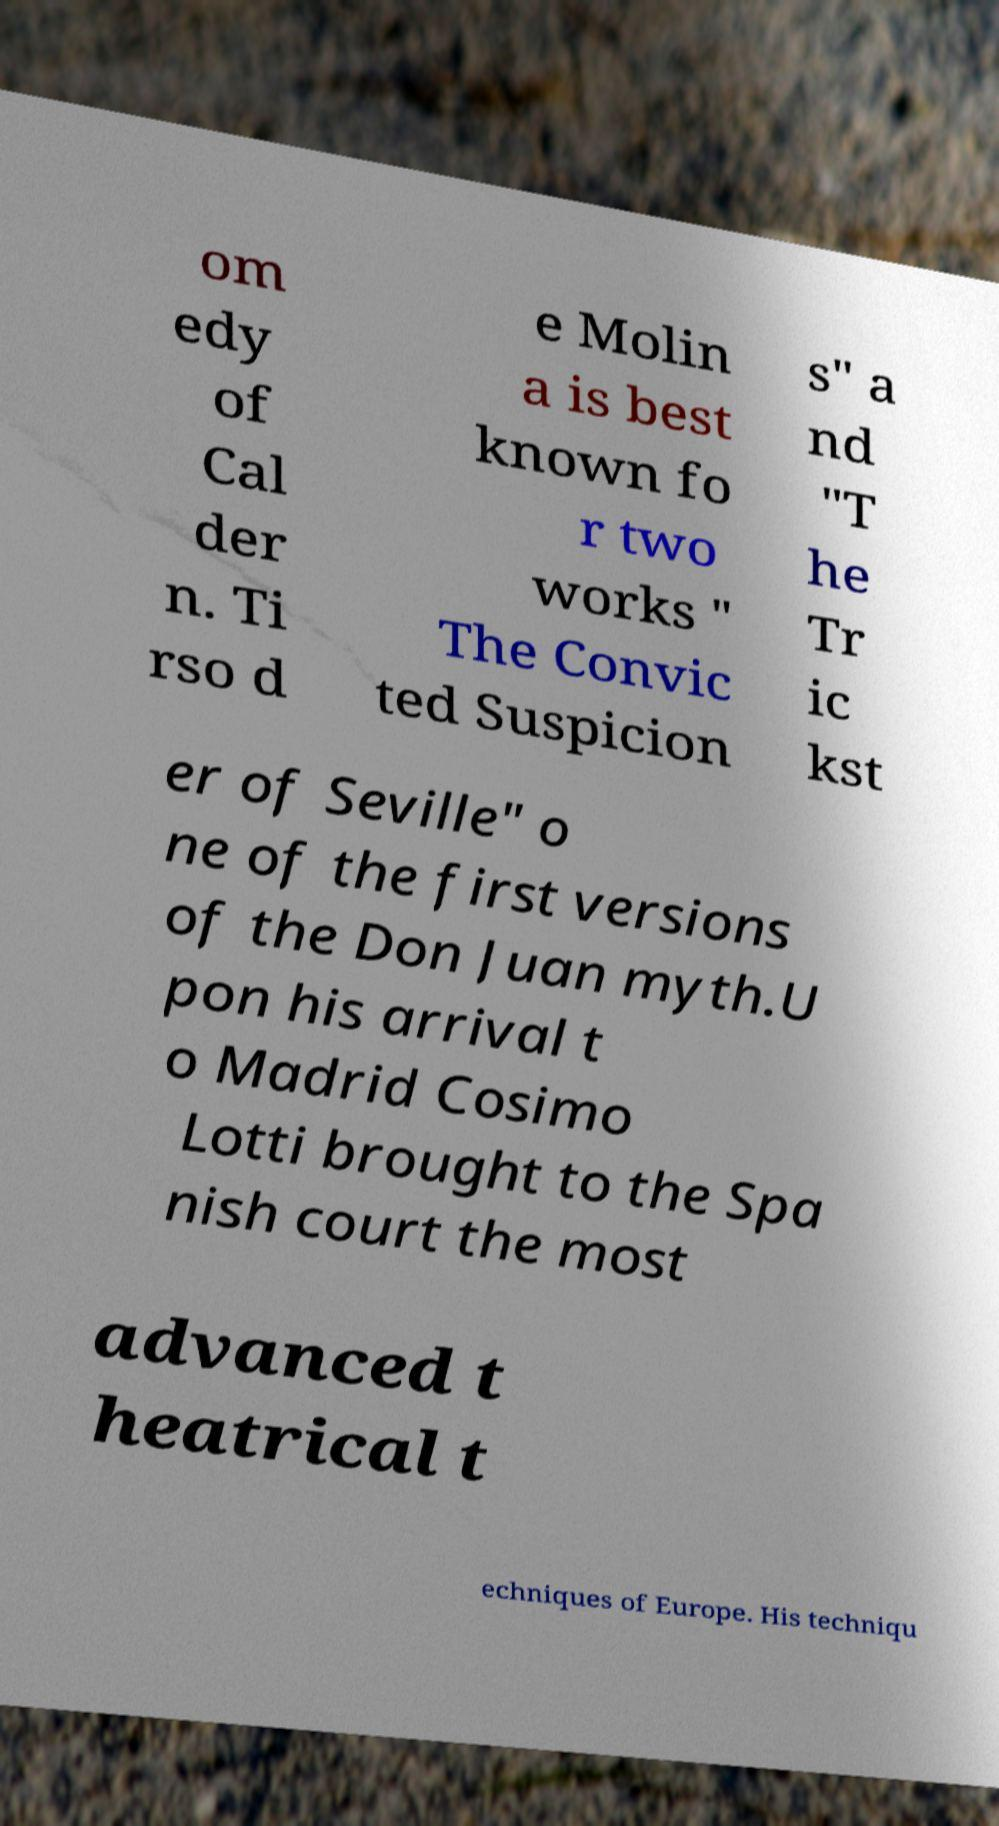Can you read and provide the text displayed in the image?This photo seems to have some interesting text. Can you extract and type it out for me? om edy of Cal der n. Ti rso d e Molin a is best known fo r two works " The Convic ted Suspicion s" a nd "T he Tr ic kst er of Seville" o ne of the first versions of the Don Juan myth.U pon his arrival t o Madrid Cosimo Lotti brought to the Spa nish court the most advanced t heatrical t echniques of Europe. His techniqu 